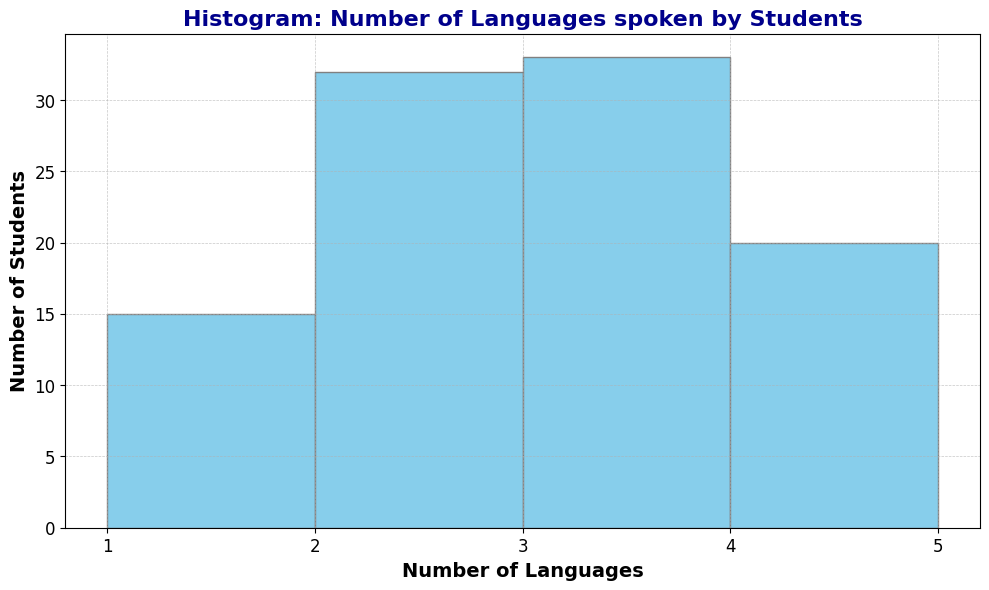What's the most common number of languages spoken by students? Look at the bar with the highest frequency. The bar representing "3 languages" is the tallest, indicating it is the most common number of languages spoken.
Answer: 3 languages Which number of languages has the least number of students speaking them? Identify the shortest bar in the histogram. The bar representing "1 language" is the shortest, indicating it has the least number of students.
Answer: 1 language How many students speak exactly 2 languages? Look at the height of the bar corresponding to "2 languages." The number of students who speak exactly 2 languages is given by the height of this bar.
Answer: 25 students Is the number of students speaking 4 languages greater than those speaking 1 language? Compare the heights of the bars for "4 languages" and "1 language." The bar for "4 languages" is taller than the bar for "1 language."
Answer: Yes What's the difference between the number of students who speak 3 languages and those who speak 2 languages? Subtract the number of students who speak 2 languages from those who speak 3 languages. There are 35 students who speak 3 languages and 25 students who speak 2 languages, so the difference is 35 - 25 = 10.
Answer: 10 students What is the total number of students who speak either 1 or 4 languages? Add the number of students who speak 1 language to the number of students who speak 4 languages. There are 10 students who speak 1 language and 15 who speak 4 languages, so the total is 10 + 15 = 25.
Answer: 25 students What percentage of students speak exactly 3 languages? Divide the number of students who speak 3 languages by the total number of students and multiply by 100. There are 35 students who speak 3 languages and a total of 100 students, so the percentage is (35/100) * 100 = 35%.
Answer: 35% Compare the number of students speaking 2 languages to those speaking more than 2 languages. Sum the number of students who speak more than 2 languages (3 and 4 languages) and compare to those who speak 2 languages. There are 35 students speaking 3 languages and 15 speaking 4 languages, totaling 50. There are 25 students speaking 2 languages, so the number speaking 2 languages is less.
Answer: Less than What is the combined number of students speaking 1, 2, and 3 languages? Sum the number of students who speak 1, 2, and 3 languages. There are 10 students speaking 1 language, 25 students speaking 2 languages, and 35 students speaking 3 languages, so the total is 10 + 25 + 35 = 70.
Answer: 70 students Determine the ratio of students who speak 3 languages to those who speak 1 language. Divide the number of students who speak 3 languages by the number of students who speak 1 language. There are 35 students who speak 3 languages and 10 students who speak 1 language, so the ratio is 35/10 or 3.5.
Answer: 3.5 